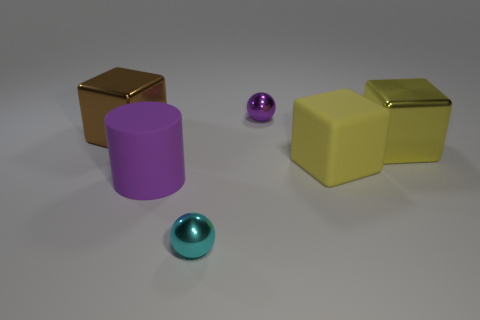There is another object that is the same shape as the cyan shiny object; what color is it?
Keep it short and to the point. Purple. There is a big metal cube that is on the right side of the big metallic block to the left of the cyan metallic sphere; are there any things in front of it?
Your response must be concise. Yes. Is the big brown thing the same shape as the yellow rubber thing?
Your response must be concise. Yes. Is the number of yellow metallic cubes on the left side of the large cylinder less than the number of big brown metallic blocks?
Make the answer very short. Yes. What color is the tiny thing that is in front of the big cube that is behind the large yellow metal block that is on the right side of the brown metallic thing?
Offer a very short reply. Cyan. How many matte objects are either big purple things or big red cylinders?
Your answer should be very brief. 1. Is the yellow matte block the same size as the cyan sphere?
Ensure brevity in your answer.  No. Are there fewer spheres right of the brown block than things that are right of the cyan object?
Give a very brief answer. Yes. The yellow matte cube is what size?
Make the answer very short. Large. How many tiny things are either metallic balls or purple cylinders?
Offer a terse response. 2. 